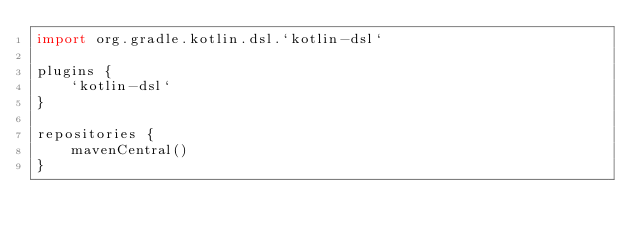Convert code to text. <code><loc_0><loc_0><loc_500><loc_500><_Kotlin_>import org.gradle.kotlin.dsl.`kotlin-dsl`

plugins {
    `kotlin-dsl`
}

repositories {
    mavenCentral()
}
</code> 